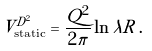Convert formula to latex. <formula><loc_0><loc_0><loc_500><loc_500>V _ { \text {static} } ^ { D ^ { 2 } } = \frac { Q ^ { 2 } } { 2 \pi } \ln \lambda R \, .</formula> 